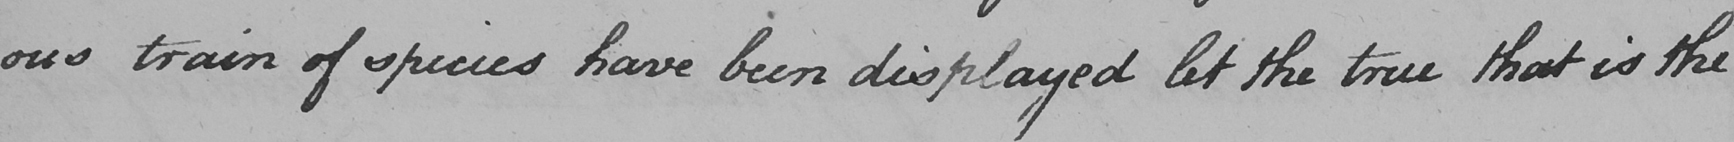What does this handwritten line say? ous train of species have been displayed let the true that is the 